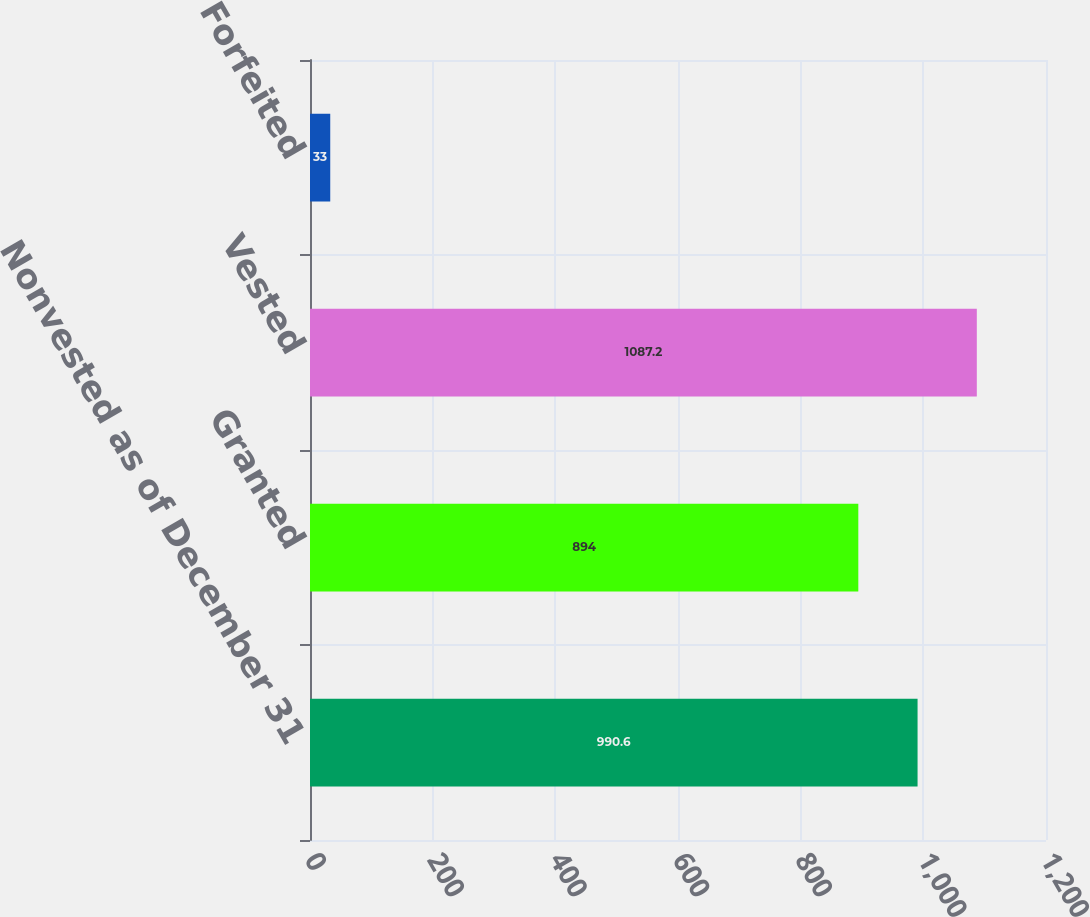<chart> <loc_0><loc_0><loc_500><loc_500><bar_chart><fcel>Nonvested as of December 31<fcel>Granted<fcel>Vested<fcel>Forfeited<nl><fcel>990.6<fcel>894<fcel>1087.2<fcel>33<nl></chart> 